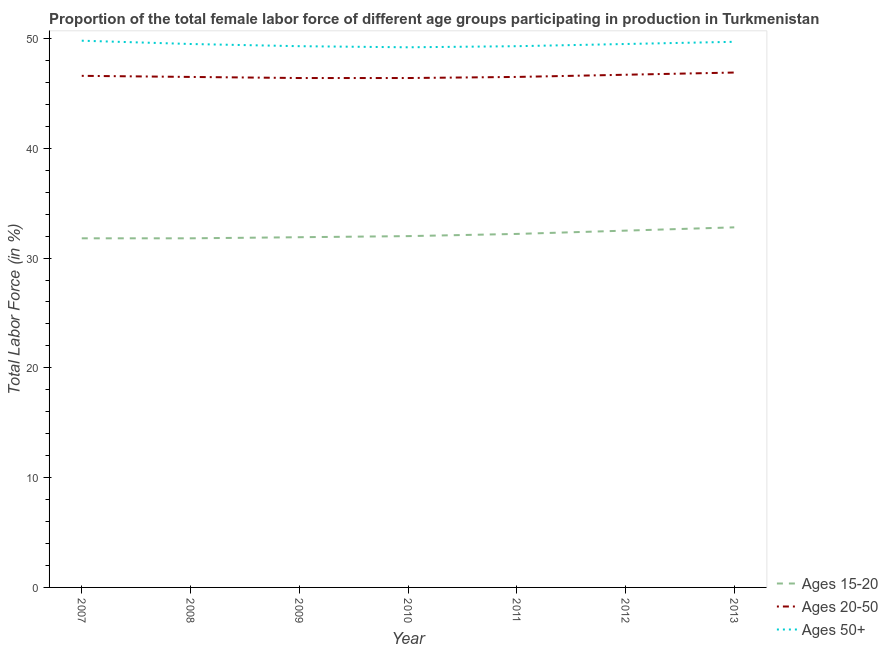How many different coloured lines are there?
Offer a terse response. 3. Does the line corresponding to percentage of female labor force within the age group 15-20 intersect with the line corresponding to percentage of female labor force within the age group 20-50?
Your response must be concise. No. Is the number of lines equal to the number of legend labels?
Ensure brevity in your answer.  Yes. What is the percentage of female labor force above age 50 in 2010?
Your answer should be very brief. 49.2. Across all years, what is the maximum percentage of female labor force above age 50?
Give a very brief answer. 49.8. Across all years, what is the minimum percentage of female labor force above age 50?
Your answer should be compact. 49.2. In which year was the percentage of female labor force within the age group 15-20 minimum?
Your answer should be compact. 2007. What is the total percentage of female labor force within the age group 15-20 in the graph?
Your answer should be very brief. 225. What is the difference between the percentage of female labor force within the age group 15-20 in 2007 and that in 2011?
Offer a terse response. -0.4. What is the difference between the percentage of female labor force above age 50 in 2007 and the percentage of female labor force within the age group 15-20 in 2011?
Ensure brevity in your answer.  17.6. What is the average percentage of female labor force within the age group 20-50 per year?
Your answer should be compact. 46.57. In the year 2008, what is the difference between the percentage of female labor force above age 50 and percentage of female labor force within the age group 20-50?
Keep it short and to the point. 3. What is the ratio of the percentage of female labor force within the age group 15-20 in 2007 to that in 2013?
Your answer should be compact. 0.97. Is the percentage of female labor force above age 50 in 2010 less than that in 2011?
Your answer should be compact. Yes. Is the difference between the percentage of female labor force within the age group 20-50 in 2008 and 2009 greater than the difference between the percentage of female labor force above age 50 in 2008 and 2009?
Make the answer very short. No. What is the difference between the highest and the second highest percentage of female labor force above age 50?
Keep it short and to the point. 0.1. What is the difference between the highest and the lowest percentage of female labor force within the age group 15-20?
Offer a very short reply. 1. In how many years, is the percentage of female labor force within the age group 20-50 greater than the average percentage of female labor force within the age group 20-50 taken over all years?
Your answer should be very brief. 3. How many lines are there?
Your answer should be very brief. 3. Does the graph contain any zero values?
Provide a short and direct response. No. Does the graph contain grids?
Make the answer very short. No. How are the legend labels stacked?
Your answer should be very brief. Vertical. What is the title of the graph?
Offer a terse response. Proportion of the total female labor force of different age groups participating in production in Turkmenistan. Does "Oil sources" appear as one of the legend labels in the graph?
Provide a succinct answer. No. What is the label or title of the X-axis?
Ensure brevity in your answer.  Year. What is the Total Labor Force (in %) of Ages 15-20 in 2007?
Keep it short and to the point. 31.8. What is the Total Labor Force (in %) of Ages 20-50 in 2007?
Keep it short and to the point. 46.6. What is the Total Labor Force (in %) of Ages 50+ in 2007?
Make the answer very short. 49.8. What is the Total Labor Force (in %) in Ages 15-20 in 2008?
Provide a succinct answer. 31.8. What is the Total Labor Force (in %) of Ages 20-50 in 2008?
Provide a short and direct response. 46.5. What is the Total Labor Force (in %) in Ages 50+ in 2008?
Your answer should be very brief. 49.5. What is the Total Labor Force (in %) of Ages 15-20 in 2009?
Make the answer very short. 31.9. What is the Total Labor Force (in %) of Ages 20-50 in 2009?
Give a very brief answer. 46.4. What is the Total Labor Force (in %) in Ages 50+ in 2009?
Provide a succinct answer. 49.3. What is the Total Labor Force (in %) of Ages 15-20 in 2010?
Offer a very short reply. 32. What is the Total Labor Force (in %) in Ages 20-50 in 2010?
Ensure brevity in your answer.  46.4. What is the Total Labor Force (in %) in Ages 50+ in 2010?
Ensure brevity in your answer.  49.2. What is the Total Labor Force (in %) in Ages 15-20 in 2011?
Keep it short and to the point. 32.2. What is the Total Labor Force (in %) in Ages 20-50 in 2011?
Provide a short and direct response. 46.5. What is the Total Labor Force (in %) in Ages 50+ in 2011?
Your answer should be compact. 49.3. What is the Total Labor Force (in %) of Ages 15-20 in 2012?
Provide a succinct answer. 32.5. What is the Total Labor Force (in %) of Ages 20-50 in 2012?
Ensure brevity in your answer.  46.7. What is the Total Labor Force (in %) in Ages 50+ in 2012?
Offer a terse response. 49.5. What is the Total Labor Force (in %) in Ages 15-20 in 2013?
Offer a terse response. 32.8. What is the Total Labor Force (in %) in Ages 20-50 in 2013?
Keep it short and to the point. 46.9. What is the Total Labor Force (in %) in Ages 50+ in 2013?
Provide a succinct answer. 49.7. Across all years, what is the maximum Total Labor Force (in %) of Ages 15-20?
Offer a very short reply. 32.8. Across all years, what is the maximum Total Labor Force (in %) in Ages 20-50?
Your response must be concise. 46.9. Across all years, what is the maximum Total Labor Force (in %) in Ages 50+?
Make the answer very short. 49.8. Across all years, what is the minimum Total Labor Force (in %) of Ages 15-20?
Provide a short and direct response. 31.8. Across all years, what is the minimum Total Labor Force (in %) of Ages 20-50?
Your response must be concise. 46.4. Across all years, what is the minimum Total Labor Force (in %) of Ages 50+?
Your answer should be compact. 49.2. What is the total Total Labor Force (in %) in Ages 15-20 in the graph?
Give a very brief answer. 225. What is the total Total Labor Force (in %) of Ages 20-50 in the graph?
Provide a succinct answer. 326. What is the total Total Labor Force (in %) in Ages 50+ in the graph?
Give a very brief answer. 346.3. What is the difference between the Total Labor Force (in %) of Ages 15-20 in 2007 and that in 2008?
Provide a short and direct response. 0. What is the difference between the Total Labor Force (in %) in Ages 20-50 in 2007 and that in 2008?
Offer a terse response. 0.1. What is the difference between the Total Labor Force (in %) of Ages 20-50 in 2007 and that in 2009?
Make the answer very short. 0.2. What is the difference between the Total Labor Force (in %) in Ages 50+ in 2007 and that in 2009?
Ensure brevity in your answer.  0.5. What is the difference between the Total Labor Force (in %) in Ages 20-50 in 2007 and that in 2010?
Provide a succinct answer. 0.2. What is the difference between the Total Labor Force (in %) of Ages 15-20 in 2007 and that in 2011?
Offer a terse response. -0.4. What is the difference between the Total Labor Force (in %) in Ages 15-20 in 2007 and that in 2012?
Ensure brevity in your answer.  -0.7. What is the difference between the Total Labor Force (in %) in Ages 20-50 in 2007 and that in 2012?
Offer a terse response. -0.1. What is the difference between the Total Labor Force (in %) in Ages 20-50 in 2007 and that in 2013?
Provide a short and direct response. -0.3. What is the difference between the Total Labor Force (in %) in Ages 50+ in 2007 and that in 2013?
Your answer should be compact. 0.1. What is the difference between the Total Labor Force (in %) of Ages 20-50 in 2008 and that in 2010?
Ensure brevity in your answer.  0.1. What is the difference between the Total Labor Force (in %) in Ages 50+ in 2008 and that in 2010?
Ensure brevity in your answer.  0.3. What is the difference between the Total Labor Force (in %) of Ages 20-50 in 2008 and that in 2011?
Make the answer very short. 0. What is the difference between the Total Labor Force (in %) in Ages 50+ in 2008 and that in 2011?
Make the answer very short. 0.2. What is the difference between the Total Labor Force (in %) of Ages 15-20 in 2008 and that in 2012?
Your answer should be very brief. -0.7. What is the difference between the Total Labor Force (in %) in Ages 50+ in 2008 and that in 2012?
Your answer should be very brief. 0. What is the difference between the Total Labor Force (in %) of Ages 15-20 in 2008 and that in 2013?
Ensure brevity in your answer.  -1. What is the difference between the Total Labor Force (in %) in Ages 20-50 in 2008 and that in 2013?
Offer a terse response. -0.4. What is the difference between the Total Labor Force (in %) of Ages 50+ in 2008 and that in 2013?
Offer a terse response. -0.2. What is the difference between the Total Labor Force (in %) in Ages 20-50 in 2009 and that in 2010?
Your answer should be compact. 0. What is the difference between the Total Labor Force (in %) of Ages 50+ in 2009 and that in 2011?
Give a very brief answer. 0. What is the difference between the Total Labor Force (in %) in Ages 50+ in 2009 and that in 2012?
Ensure brevity in your answer.  -0.2. What is the difference between the Total Labor Force (in %) of Ages 15-20 in 2009 and that in 2013?
Your response must be concise. -0.9. What is the difference between the Total Labor Force (in %) in Ages 15-20 in 2010 and that in 2011?
Provide a succinct answer. -0.2. What is the difference between the Total Labor Force (in %) of Ages 50+ in 2010 and that in 2011?
Give a very brief answer. -0.1. What is the difference between the Total Labor Force (in %) of Ages 15-20 in 2010 and that in 2013?
Your response must be concise. -0.8. What is the difference between the Total Labor Force (in %) in Ages 20-50 in 2010 and that in 2013?
Give a very brief answer. -0.5. What is the difference between the Total Labor Force (in %) in Ages 15-20 in 2011 and that in 2012?
Provide a succinct answer. -0.3. What is the difference between the Total Labor Force (in %) in Ages 15-20 in 2011 and that in 2013?
Provide a succinct answer. -0.6. What is the difference between the Total Labor Force (in %) in Ages 50+ in 2011 and that in 2013?
Provide a succinct answer. -0.4. What is the difference between the Total Labor Force (in %) of Ages 15-20 in 2007 and the Total Labor Force (in %) of Ages 20-50 in 2008?
Ensure brevity in your answer.  -14.7. What is the difference between the Total Labor Force (in %) of Ages 15-20 in 2007 and the Total Labor Force (in %) of Ages 50+ in 2008?
Keep it short and to the point. -17.7. What is the difference between the Total Labor Force (in %) in Ages 20-50 in 2007 and the Total Labor Force (in %) in Ages 50+ in 2008?
Offer a terse response. -2.9. What is the difference between the Total Labor Force (in %) in Ages 15-20 in 2007 and the Total Labor Force (in %) in Ages 20-50 in 2009?
Offer a very short reply. -14.6. What is the difference between the Total Labor Force (in %) in Ages 15-20 in 2007 and the Total Labor Force (in %) in Ages 50+ in 2009?
Offer a terse response. -17.5. What is the difference between the Total Labor Force (in %) in Ages 20-50 in 2007 and the Total Labor Force (in %) in Ages 50+ in 2009?
Your response must be concise. -2.7. What is the difference between the Total Labor Force (in %) of Ages 15-20 in 2007 and the Total Labor Force (in %) of Ages 20-50 in 2010?
Offer a terse response. -14.6. What is the difference between the Total Labor Force (in %) in Ages 15-20 in 2007 and the Total Labor Force (in %) in Ages 50+ in 2010?
Provide a succinct answer. -17.4. What is the difference between the Total Labor Force (in %) in Ages 15-20 in 2007 and the Total Labor Force (in %) in Ages 20-50 in 2011?
Offer a very short reply. -14.7. What is the difference between the Total Labor Force (in %) of Ages 15-20 in 2007 and the Total Labor Force (in %) of Ages 50+ in 2011?
Ensure brevity in your answer.  -17.5. What is the difference between the Total Labor Force (in %) of Ages 15-20 in 2007 and the Total Labor Force (in %) of Ages 20-50 in 2012?
Your answer should be compact. -14.9. What is the difference between the Total Labor Force (in %) of Ages 15-20 in 2007 and the Total Labor Force (in %) of Ages 50+ in 2012?
Keep it short and to the point. -17.7. What is the difference between the Total Labor Force (in %) of Ages 20-50 in 2007 and the Total Labor Force (in %) of Ages 50+ in 2012?
Provide a succinct answer. -2.9. What is the difference between the Total Labor Force (in %) in Ages 15-20 in 2007 and the Total Labor Force (in %) in Ages 20-50 in 2013?
Provide a short and direct response. -15.1. What is the difference between the Total Labor Force (in %) of Ages 15-20 in 2007 and the Total Labor Force (in %) of Ages 50+ in 2013?
Your answer should be compact. -17.9. What is the difference between the Total Labor Force (in %) of Ages 15-20 in 2008 and the Total Labor Force (in %) of Ages 20-50 in 2009?
Your response must be concise. -14.6. What is the difference between the Total Labor Force (in %) in Ages 15-20 in 2008 and the Total Labor Force (in %) in Ages 50+ in 2009?
Offer a terse response. -17.5. What is the difference between the Total Labor Force (in %) in Ages 20-50 in 2008 and the Total Labor Force (in %) in Ages 50+ in 2009?
Offer a terse response. -2.8. What is the difference between the Total Labor Force (in %) in Ages 15-20 in 2008 and the Total Labor Force (in %) in Ages 20-50 in 2010?
Your answer should be very brief. -14.6. What is the difference between the Total Labor Force (in %) in Ages 15-20 in 2008 and the Total Labor Force (in %) in Ages 50+ in 2010?
Provide a short and direct response. -17.4. What is the difference between the Total Labor Force (in %) of Ages 15-20 in 2008 and the Total Labor Force (in %) of Ages 20-50 in 2011?
Give a very brief answer. -14.7. What is the difference between the Total Labor Force (in %) of Ages 15-20 in 2008 and the Total Labor Force (in %) of Ages 50+ in 2011?
Provide a succinct answer. -17.5. What is the difference between the Total Labor Force (in %) of Ages 15-20 in 2008 and the Total Labor Force (in %) of Ages 20-50 in 2012?
Ensure brevity in your answer.  -14.9. What is the difference between the Total Labor Force (in %) of Ages 15-20 in 2008 and the Total Labor Force (in %) of Ages 50+ in 2012?
Offer a terse response. -17.7. What is the difference between the Total Labor Force (in %) of Ages 15-20 in 2008 and the Total Labor Force (in %) of Ages 20-50 in 2013?
Give a very brief answer. -15.1. What is the difference between the Total Labor Force (in %) in Ages 15-20 in 2008 and the Total Labor Force (in %) in Ages 50+ in 2013?
Offer a very short reply. -17.9. What is the difference between the Total Labor Force (in %) of Ages 20-50 in 2008 and the Total Labor Force (in %) of Ages 50+ in 2013?
Keep it short and to the point. -3.2. What is the difference between the Total Labor Force (in %) of Ages 15-20 in 2009 and the Total Labor Force (in %) of Ages 20-50 in 2010?
Your answer should be very brief. -14.5. What is the difference between the Total Labor Force (in %) of Ages 15-20 in 2009 and the Total Labor Force (in %) of Ages 50+ in 2010?
Your answer should be very brief. -17.3. What is the difference between the Total Labor Force (in %) in Ages 20-50 in 2009 and the Total Labor Force (in %) in Ages 50+ in 2010?
Ensure brevity in your answer.  -2.8. What is the difference between the Total Labor Force (in %) in Ages 15-20 in 2009 and the Total Labor Force (in %) in Ages 20-50 in 2011?
Your answer should be compact. -14.6. What is the difference between the Total Labor Force (in %) in Ages 15-20 in 2009 and the Total Labor Force (in %) in Ages 50+ in 2011?
Your answer should be compact. -17.4. What is the difference between the Total Labor Force (in %) in Ages 20-50 in 2009 and the Total Labor Force (in %) in Ages 50+ in 2011?
Ensure brevity in your answer.  -2.9. What is the difference between the Total Labor Force (in %) in Ages 15-20 in 2009 and the Total Labor Force (in %) in Ages 20-50 in 2012?
Your answer should be compact. -14.8. What is the difference between the Total Labor Force (in %) in Ages 15-20 in 2009 and the Total Labor Force (in %) in Ages 50+ in 2012?
Offer a terse response. -17.6. What is the difference between the Total Labor Force (in %) of Ages 15-20 in 2009 and the Total Labor Force (in %) of Ages 20-50 in 2013?
Provide a short and direct response. -15. What is the difference between the Total Labor Force (in %) of Ages 15-20 in 2009 and the Total Labor Force (in %) of Ages 50+ in 2013?
Your response must be concise. -17.8. What is the difference between the Total Labor Force (in %) in Ages 20-50 in 2009 and the Total Labor Force (in %) in Ages 50+ in 2013?
Offer a very short reply. -3.3. What is the difference between the Total Labor Force (in %) of Ages 15-20 in 2010 and the Total Labor Force (in %) of Ages 50+ in 2011?
Offer a very short reply. -17.3. What is the difference between the Total Labor Force (in %) of Ages 20-50 in 2010 and the Total Labor Force (in %) of Ages 50+ in 2011?
Your response must be concise. -2.9. What is the difference between the Total Labor Force (in %) in Ages 15-20 in 2010 and the Total Labor Force (in %) in Ages 20-50 in 2012?
Provide a short and direct response. -14.7. What is the difference between the Total Labor Force (in %) in Ages 15-20 in 2010 and the Total Labor Force (in %) in Ages 50+ in 2012?
Your response must be concise. -17.5. What is the difference between the Total Labor Force (in %) in Ages 20-50 in 2010 and the Total Labor Force (in %) in Ages 50+ in 2012?
Provide a succinct answer. -3.1. What is the difference between the Total Labor Force (in %) of Ages 15-20 in 2010 and the Total Labor Force (in %) of Ages 20-50 in 2013?
Ensure brevity in your answer.  -14.9. What is the difference between the Total Labor Force (in %) of Ages 15-20 in 2010 and the Total Labor Force (in %) of Ages 50+ in 2013?
Your answer should be very brief. -17.7. What is the difference between the Total Labor Force (in %) of Ages 20-50 in 2010 and the Total Labor Force (in %) of Ages 50+ in 2013?
Offer a terse response. -3.3. What is the difference between the Total Labor Force (in %) of Ages 15-20 in 2011 and the Total Labor Force (in %) of Ages 50+ in 2012?
Keep it short and to the point. -17.3. What is the difference between the Total Labor Force (in %) in Ages 20-50 in 2011 and the Total Labor Force (in %) in Ages 50+ in 2012?
Your answer should be very brief. -3. What is the difference between the Total Labor Force (in %) in Ages 15-20 in 2011 and the Total Labor Force (in %) in Ages 20-50 in 2013?
Offer a terse response. -14.7. What is the difference between the Total Labor Force (in %) of Ages 15-20 in 2011 and the Total Labor Force (in %) of Ages 50+ in 2013?
Provide a short and direct response. -17.5. What is the difference between the Total Labor Force (in %) of Ages 15-20 in 2012 and the Total Labor Force (in %) of Ages 20-50 in 2013?
Make the answer very short. -14.4. What is the difference between the Total Labor Force (in %) in Ages 15-20 in 2012 and the Total Labor Force (in %) in Ages 50+ in 2013?
Provide a succinct answer. -17.2. What is the difference between the Total Labor Force (in %) of Ages 20-50 in 2012 and the Total Labor Force (in %) of Ages 50+ in 2013?
Ensure brevity in your answer.  -3. What is the average Total Labor Force (in %) of Ages 15-20 per year?
Provide a short and direct response. 32.14. What is the average Total Labor Force (in %) in Ages 20-50 per year?
Offer a terse response. 46.57. What is the average Total Labor Force (in %) of Ages 50+ per year?
Make the answer very short. 49.47. In the year 2007, what is the difference between the Total Labor Force (in %) in Ages 15-20 and Total Labor Force (in %) in Ages 20-50?
Offer a very short reply. -14.8. In the year 2007, what is the difference between the Total Labor Force (in %) of Ages 15-20 and Total Labor Force (in %) of Ages 50+?
Your response must be concise. -18. In the year 2007, what is the difference between the Total Labor Force (in %) of Ages 20-50 and Total Labor Force (in %) of Ages 50+?
Offer a terse response. -3.2. In the year 2008, what is the difference between the Total Labor Force (in %) of Ages 15-20 and Total Labor Force (in %) of Ages 20-50?
Make the answer very short. -14.7. In the year 2008, what is the difference between the Total Labor Force (in %) of Ages 15-20 and Total Labor Force (in %) of Ages 50+?
Your answer should be compact. -17.7. In the year 2009, what is the difference between the Total Labor Force (in %) in Ages 15-20 and Total Labor Force (in %) in Ages 20-50?
Provide a succinct answer. -14.5. In the year 2009, what is the difference between the Total Labor Force (in %) in Ages 15-20 and Total Labor Force (in %) in Ages 50+?
Your response must be concise. -17.4. In the year 2010, what is the difference between the Total Labor Force (in %) of Ages 15-20 and Total Labor Force (in %) of Ages 20-50?
Give a very brief answer. -14.4. In the year 2010, what is the difference between the Total Labor Force (in %) in Ages 15-20 and Total Labor Force (in %) in Ages 50+?
Keep it short and to the point. -17.2. In the year 2011, what is the difference between the Total Labor Force (in %) of Ages 15-20 and Total Labor Force (in %) of Ages 20-50?
Keep it short and to the point. -14.3. In the year 2011, what is the difference between the Total Labor Force (in %) in Ages 15-20 and Total Labor Force (in %) in Ages 50+?
Give a very brief answer. -17.1. In the year 2012, what is the difference between the Total Labor Force (in %) in Ages 15-20 and Total Labor Force (in %) in Ages 20-50?
Give a very brief answer. -14.2. In the year 2013, what is the difference between the Total Labor Force (in %) of Ages 15-20 and Total Labor Force (in %) of Ages 20-50?
Provide a short and direct response. -14.1. In the year 2013, what is the difference between the Total Labor Force (in %) of Ages 15-20 and Total Labor Force (in %) of Ages 50+?
Your answer should be compact. -16.9. In the year 2013, what is the difference between the Total Labor Force (in %) in Ages 20-50 and Total Labor Force (in %) in Ages 50+?
Offer a very short reply. -2.8. What is the ratio of the Total Labor Force (in %) in Ages 50+ in 2007 to that in 2008?
Your response must be concise. 1.01. What is the ratio of the Total Labor Force (in %) of Ages 15-20 in 2007 to that in 2009?
Provide a short and direct response. 1. What is the ratio of the Total Labor Force (in %) in Ages 20-50 in 2007 to that in 2010?
Ensure brevity in your answer.  1. What is the ratio of the Total Labor Force (in %) in Ages 50+ in 2007 to that in 2010?
Give a very brief answer. 1.01. What is the ratio of the Total Labor Force (in %) of Ages 15-20 in 2007 to that in 2011?
Offer a terse response. 0.99. What is the ratio of the Total Labor Force (in %) of Ages 50+ in 2007 to that in 2011?
Provide a short and direct response. 1.01. What is the ratio of the Total Labor Force (in %) of Ages 15-20 in 2007 to that in 2012?
Ensure brevity in your answer.  0.98. What is the ratio of the Total Labor Force (in %) of Ages 50+ in 2007 to that in 2012?
Your answer should be compact. 1.01. What is the ratio of the Total Labor Force (in %) of Ages 15-20 in 2007 to that in 2013?
Provide a succinct answer. 0.97. What is the ratio of the Total Labor Force (in %) of Ages 20-50 in 2007 to that in 2013?
Keep it short and to the point. 0.99. What is the ratio of the Total Labor Force (in %) of Ages 15-20 in 2008 to that in 2009?
Keep it short and to the point. 1. What is the ratio of the Total Labor Force (in %) of Ages 20-50 in 2008 to that in 2009?
Offer a terse response. 1. What is the ratio of the Total Labor Force (in %) in Ages 50+ in 2008 to that in 2009?
Make the answer very short. 1. What is the ratio of the Total Labor Force (in %) in Ages 15-20 in 2008 to that in 2010?
Your answer should be very brief. 0.99. What is the ratio of the Total Labor Force (in %) of Ages 20-50 in 2008 to that in 2010?
Offer a terse response. 1. What is the ratio of the Total Labor Force (in %) in Ages 50+ in 2008 to that in 2010?
Make the answer very short. 1.01. What is the ratio of the Total Labor Force (in %) of Ages 15-20 in 2008 to that in 2011?
Ensure brevity in your answer.  0.99. What is the ratio of the Total Labor Force (in %) in Ages 15-20 in 2008 to that in 2012?
Give a very brief answer. 0.98. What is the ratio of the Total Labor Force (in %) of Ages 20-50 in 2008 to that in 2012?
Keep it short and to the point. 1. What is the ratio of the Total Labor Force (in %) of Ages 50+ in 2008 to that in 2012?
Your response must be concise. 1. What is the ratio of the Total Labor Force (in %) in Ages 15-20 in 2008 to that in 2013?
Provide a short and direct response. 0.97. What is the ratio of the Total Labor Force (in %) in Ages 20-50 in 2008 to that in 2013?
Give a very brief answer. 0.99. What is the ratio of the Total Labor Force (in %) of Ages 15-20 in 2009 to that in 2010?
Offer a terse response. 1. What is the ratio of the Total Labor Force (in %) of Ages 15-20 in 2009 to that in 2011?
Make the answer very short. 0.99. What is the ratio of the Total Labor Force (in %) of Ages 20-50 in 2009 to that in 2011?
Provide a succinct answer. 1. What is the ratio of the Total Labor Force (in %) of Ages 15-20 in 2009 to that in 2012?
Your answer should be compact. 0.98. What is the ratio of the Total Labor Force (in %) of Ages 20-50 in 2009 to that in 2012?
Your answer should be very brief. 0.99. What is the ratio of the Total Labor Force (in %) in Ages 15-20 in 2009 to that in 2013?
Ensure brevity in your answer.  0.97. What is the ratio of the Total Labor Force (in %) of Ages 20-50 in 2009 to that in 2013?
Your answer should be very brief. 0.99. What is the ratio of the Total Labor Force (in %) of Ages 20-50 in 2010 to that in 2011?
Offer a very short reply. 1. What is the ratio of the Total Labor Force (in %) in Ages 50+ in 2010 to that in 2011?
Your answer should be compact. 1. What is the ratio of the Total Labor Force (in %) of Ages 15-20 in 2010 to that in 2012?
Ensure brevity in your answer.  0.98. What is the ratio of the Total Labor Force (in %) in Ages 20-50 in 2010 to that in 2012?
Give a very brief answer. 0.99. What is the ratio of the Total Labor Force (in %) in Ages 50+ in 2010 to that in 2012?
Offer a very short reply. 0.99. What is the ratio of the Total Labor Force (in %) in Ages 15-20 in 2010 to that in 2013?
Give a very brief answer. 0.98. What is the ratio of the Total Labor Force (in %) of Ages 20-50 in 2010 to that in 2013?
Your answer should be very brief. 0.99. What is the ratio of the Total Labor Force (in %) in Ages 50+ in 2010 to that in 2013?
Keep it short and to the point. 0.99. What is the ratio of the Total Labor Force (in %) of Ages 15-20 in 2011 to that in 2012?
Give a very brief answer. 0.99. What is the ratio of the Total Labor Force (in %) of Ages 50+ in 2011 to that in 2012?
Provide a short and direct response. 1. What is the ratio of the Total Labor Force (in %) in Ages 15-20 in 2011 to that in 2013?
Your answer should be compact. 0.98. What is the ratio of the Total Labor Force (in %) of Ages 20-50 in 2011 to that in 2013?
Keep it short and to the point. 0.99. What is the ratio of the Total Labor Force (in %) in Ages 50+ in 2011 to that in 2013?
Ensure brevity in your answer.  0.99. What is the ratio of the Total Labor Force (in %) of Ages 15-20 in 2012 to that in 2013?
Your answer should be compact. 0.99. What is the ratio of the Total Labor Force (in %) in Ages 20-50 in 2012 to that in 2013?
Provide a succinct answer. 1. What is the ratio of the Total Labor Force (in %) of Ages 50+ in 2012 to that in 2013?
Offer a very short reply. 1. What is the difference between the highest and the second highest Total Labor Force (in %) in Ages 50+?
Keep it short and to the point. 0.1. What is the difference between the highest and the lowest Total Labor Force (in %) in Ages 15-20?
Ensure brevity in your answer.  1. What is the difference between the highest and the lowest Total Labor Force (in %) of Ages 50+?
Your response must be concise. 0.6. 